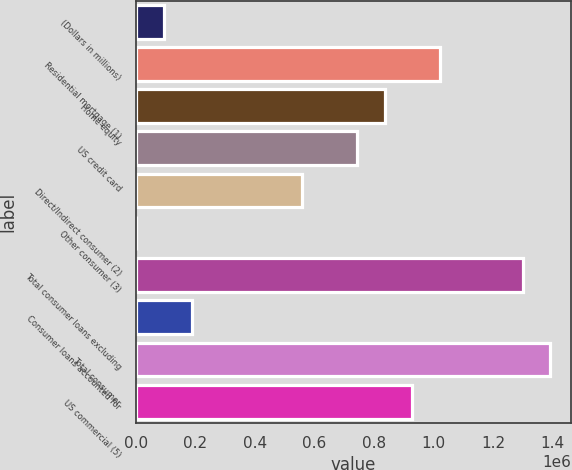Convert chart. <chart><loc_0><loc_0><loc_500><loc_500><bar_chart><fcel>(Dollars in millions)<fcel>Residential mortgage (1)<fcel>Home equity<fcel>US credit card<fcel>Direct/Indirect consumer (2)<fcel>Other consumer (3)<fcel>Total consumer loans excluding<fcel>Consumer loans accounted for<fcel>Total consumer<fcel>US commercial (5)<nl><fcel>94602.6<fcel>1.02086e+06<fcel>835607<fcel>742982<fcel>557731<fcel>1977<fcel>1.29874e+06<fcel>187228<fcel>1.39136e+06<fcel>928233<nl></chart> 